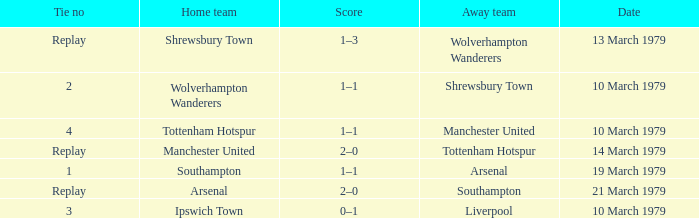Which tie number had an away team of Arsenal? 1.0. 